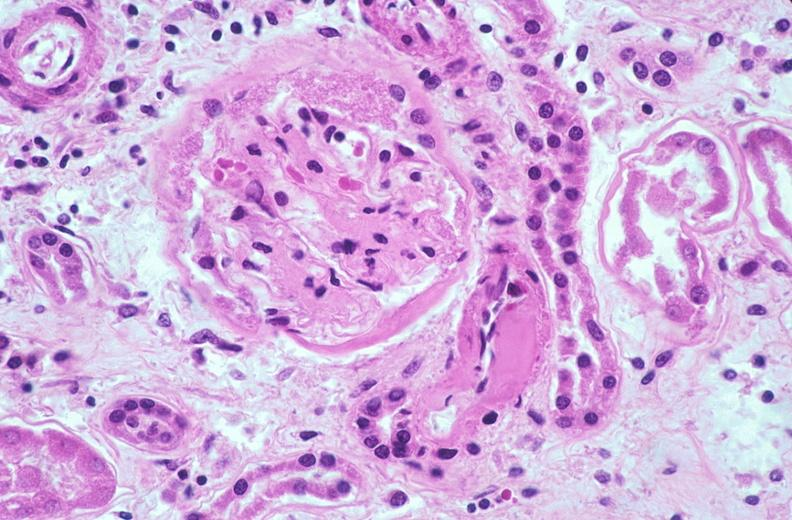what does this image show?
Answer the question using a single word or phrase. Kidney glomerulus 